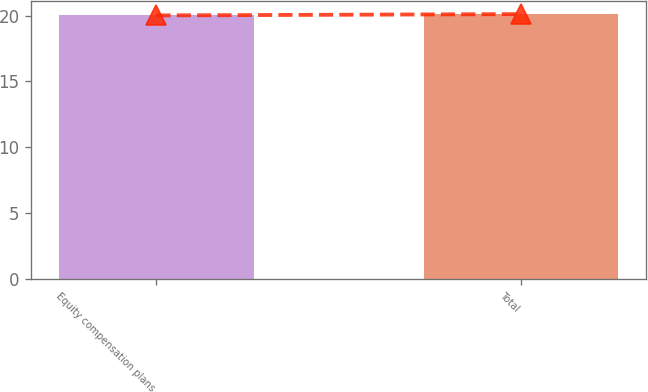Convert chart. <chart><loc_0><loc_0><loc_500><loc_500><bar_chart><fcel>Equity compensation plans<fcel>Total<nl><fcel>20.01<fcel>20.11<nl></chart> 